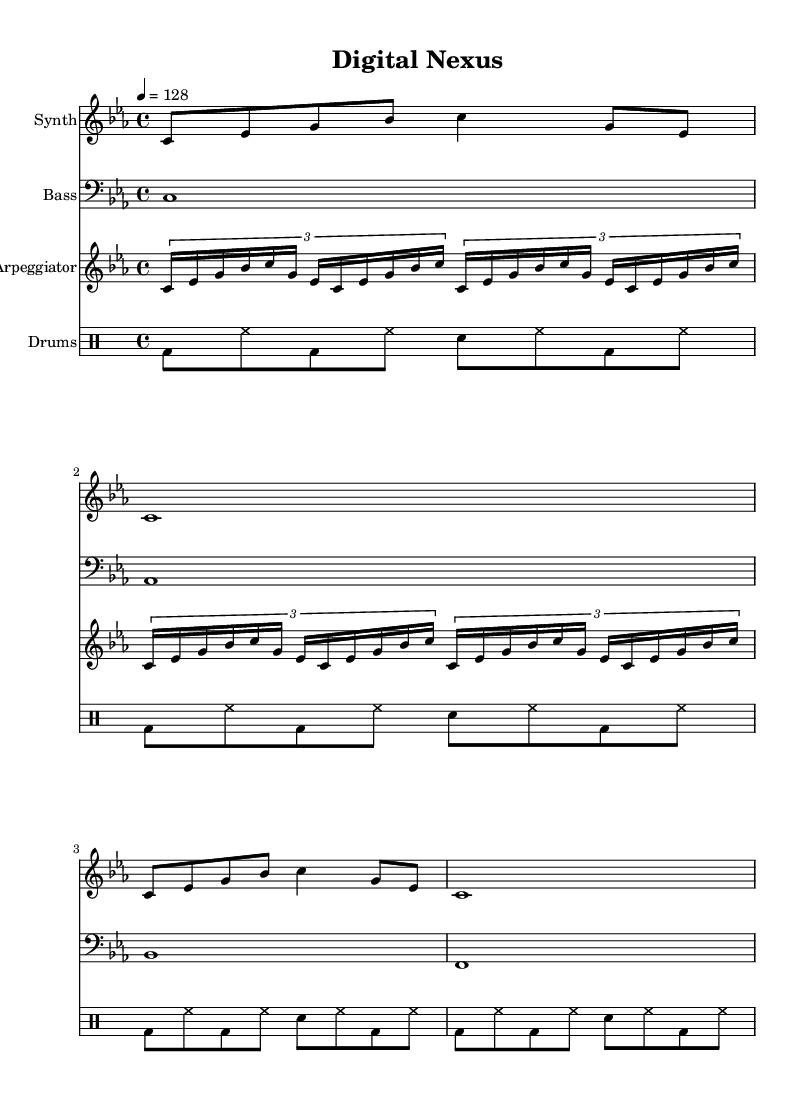What is the key signature of this music? The key signature is C minor, indicated by the presence of three flat notes (B, E, and A) which suggests that the music is in a minor key.
Answer: C minor What is the time signature of this piece? The time signature is 4/4, which means there are four beats in each measure and a quarter note gets one beat, as shown at the beginning of the score.
Answer: 4/4 What is the tempo marking for this piece? The tempo marking is indicated as 4 = 128, meaning the piece should be played at a speed of 128 beats per minute, as noted near the beginning of the score.
Answer: 128 How many measures does the synth part contain? The synth part has four measures, as visible from the notation in the staff where there are four distinct segments corresponding to the music.
Answer: 4 What instrument plays the bass line? The bass line is played by the bass instrument, as indicated in the staff layout where it specifies "Bass" for the instrument name.
Answer: Bass Which rhythmic pattern is consistently used in the drum part? The drum part consistently uses a kick (bd) and hi-hat (hh) rhythm pattern throughout, creating a driving dance beat typical for this genre.
Answer: Kick and hi-hat How does the arpeggiator contribute to the theme of futuristic dance music? The arpeggiator plays rapid sixteenth notes in a repeating pattern, which gives a tech-inspired feel and creates a lively rhythmic foundation, characteristic of futuristic dance music.
Answer: Rapid sixteenth notes 